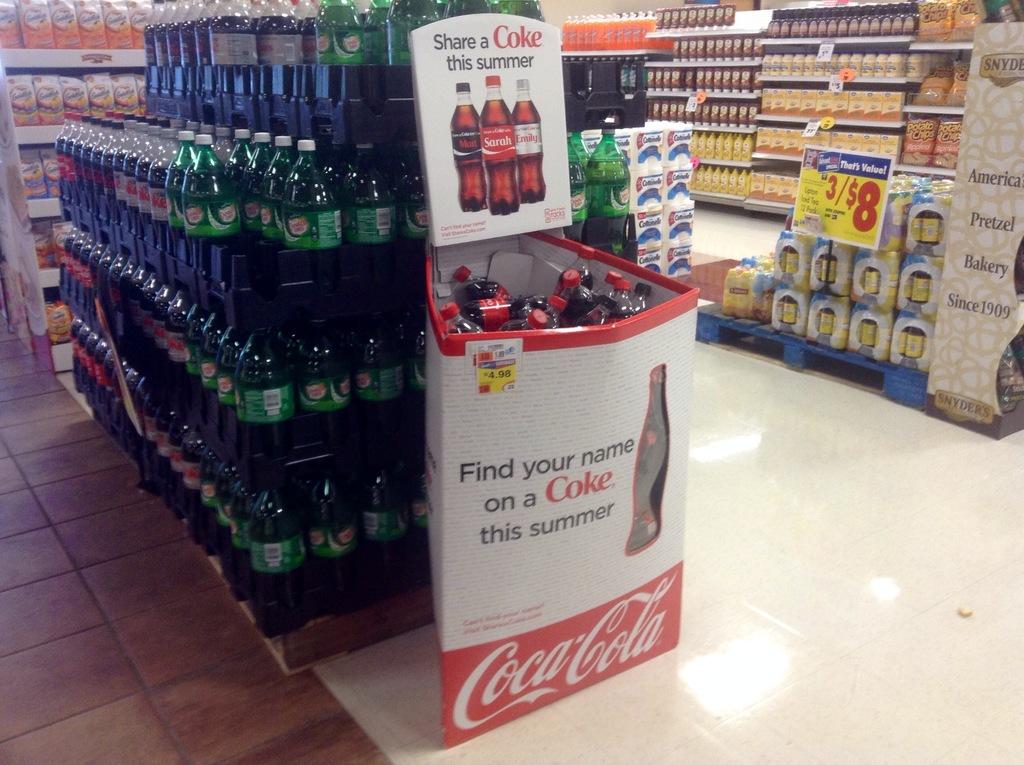What brand is this?
Ensure brevity in your answer.  Coca-cola. What slogan did coke use in this display?
Keep it short and to the point. Share a coke this summer. 